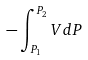Convert formula to latex. <formula><loc_0><loc_0><loc_500><loc_500>- \int _ { P _ { 1 } } ^ { P _ { 2 } } V d P</formula> 